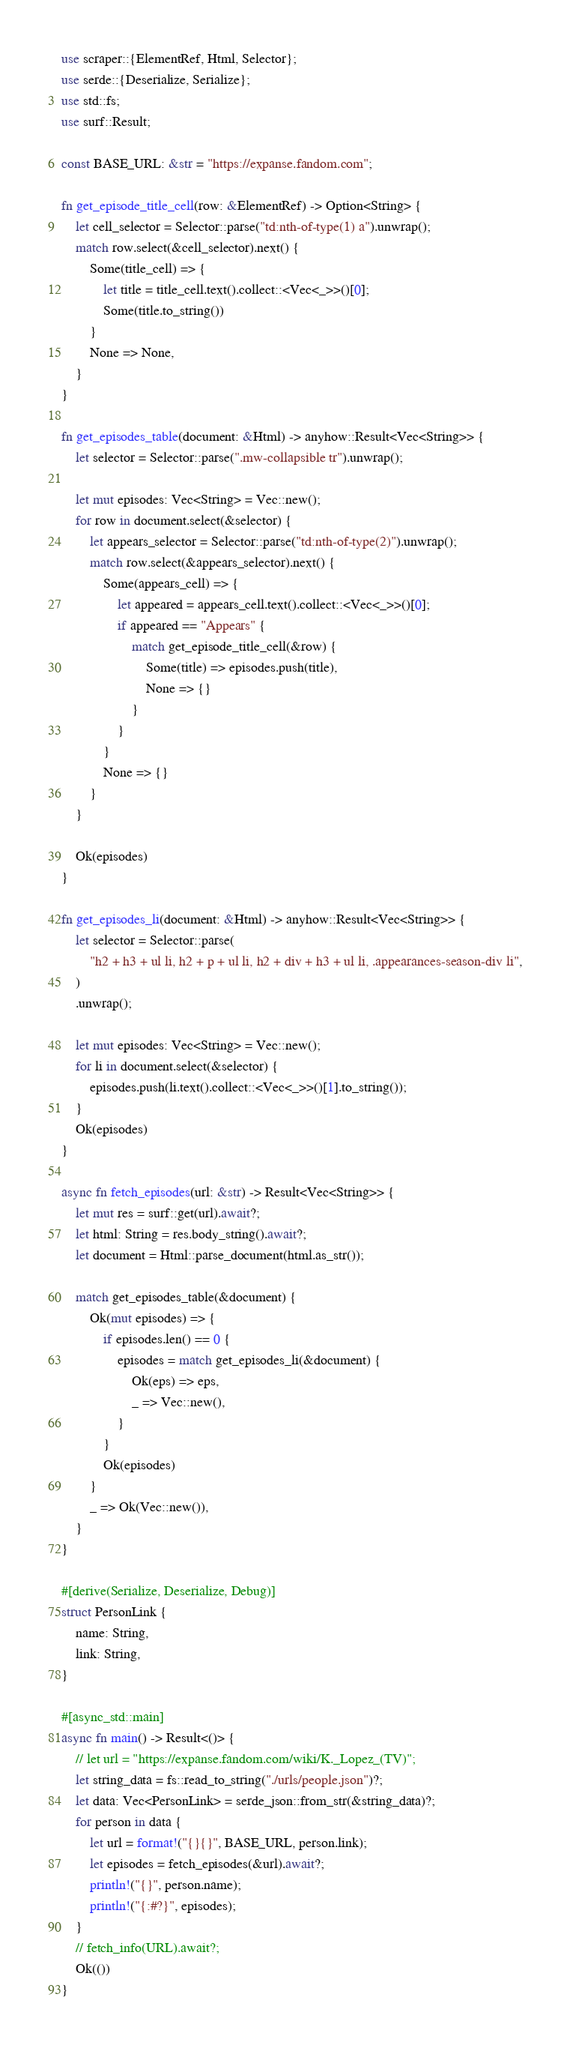Convert code to text. <code><loc_0><loc_0><loc_500><loc_500><_Rust_>use scraper::{ElementRef, Html, Selector};
use serde::{Deserialize, Serialize};
use std::fs;
use surf::Result;

const BASE_URL: &str = "https://expanse.fandom.com";

fn get_episode_title_cell(row: &ElementRef) -> Option<String> {
    let cell_selector = Selector::parse("td:nth-of-type(1) a").unwrap();
    match row.select(&cell_selector).next() {
        Some(title_cell) => {
            let title = title_cell.text().collect::<Vec<_>>()[0];
            Some(title.to_string())
        }
        None => None,
    }
}

fn get_episodes_table(document: &Html) -> anyhow::Result<Vec<String>> {
    let selector = Selector::parse(".mw-collapsible tr").unwrap();

    let mut episodes: Vec<String> = Vec::new();
    for row in document.select(&selector) {
        let appears_selector = Selector::parse("td:nth-of-type(2)").unwrap();
        match row.select(&appears_selector).next() {
            Some(appears_cell) => {
                let appeared = appears_cell.text().collect::<Vec<_>>()[0];
                if appeared == "Appears" {
                    match get_episode_title_cell(&row) {
                        Some(title) => episodes.push(title),
                        None => {}
                    }
                }
            }
            None => {}
        }
    }

    Ok(episodes)
}

fn get_episodes_li(document: &Html) -> anyhow::Result<Vec<String>> {
    let selector = Selector::parse(
        "h2 + h3 + ul li, h2 + p + ul li, h2 + div + h3 + ul li, .appearances-season-div li",
    )
    .unwrap();

    let mut episodes: Vec<String> = Vec::new();
    for li in document.select(&selector) {
        episodes.push(li.text().collect::<Vec<_>>()[1].to_string());
    }
    Ok(episodes)
}

async fn fetch_episodes(url: &str) -> Result<Vec<String>> {
    let mut res = surf::get(url).await?;
    let html: String = res.body_string().await?;
    let document = Html::parse_document(html.as_str());

    match get_episodes_table(&document) {
        Ok(mut episodes) => {
            if episodes.len() == 0 {
                episodes = match get_episodes_li(&document) {
                    Ok(eps) => eps,
                    _ => Vec::new(),
                }
            }
            Ok(episodes)
        }
        _ => Ok(Vec::new()),
    }
}

#[derive(Serialize, Deserialize, Debug)]
struct PersonLink {
    name: String,
    link: String,
}

#[async_std::main]
async fn main() -> Result<()> {
    // let url = "https://expanse.fandom.com/wiki/K._Lopez_(TV)";
    let string_data = fs::read_to_string("./urls/people.json")?;
    let data: Vec<PersonLink> = serde_json::from_str(&string_data)?;
    for person in data {
        let url = format!("{}{}", BASE_URL, person.link);
        let episodes = fetch_episodes(&url).await?;
        println!("{}", person.name);
        println!("{:#?}", episodes);
    }
    // fetch_info(URL).await?;
    Ok(())
}
</code> 